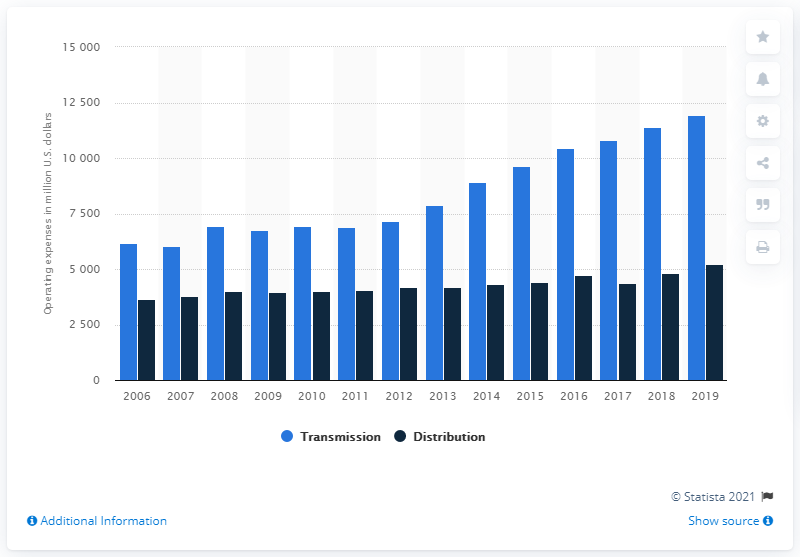Draw attention to some important aspects in this diagram. In 2019, major U.S. investor-owned electric utilities spent a significant amount on transmission operations. Specifically, the amount spent was 11,941. Operating costs peaked in 2019. 